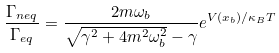Convert formula to latex. <formula><loc_0><loc_0><loc_500><loc_500>\frac { \Gamma _ { n e q } } { \Gamma _ { e q } } = \frac { 2 m \omega _ { b } } { \sqrt { \gamma ^ { 2 } + 4 m ^ { 2 } \omega ^ { 2 } _ { b } } - \gamma } e ^ { V ( x _ { b } ) / \kappa _ { B } T }</formula> 